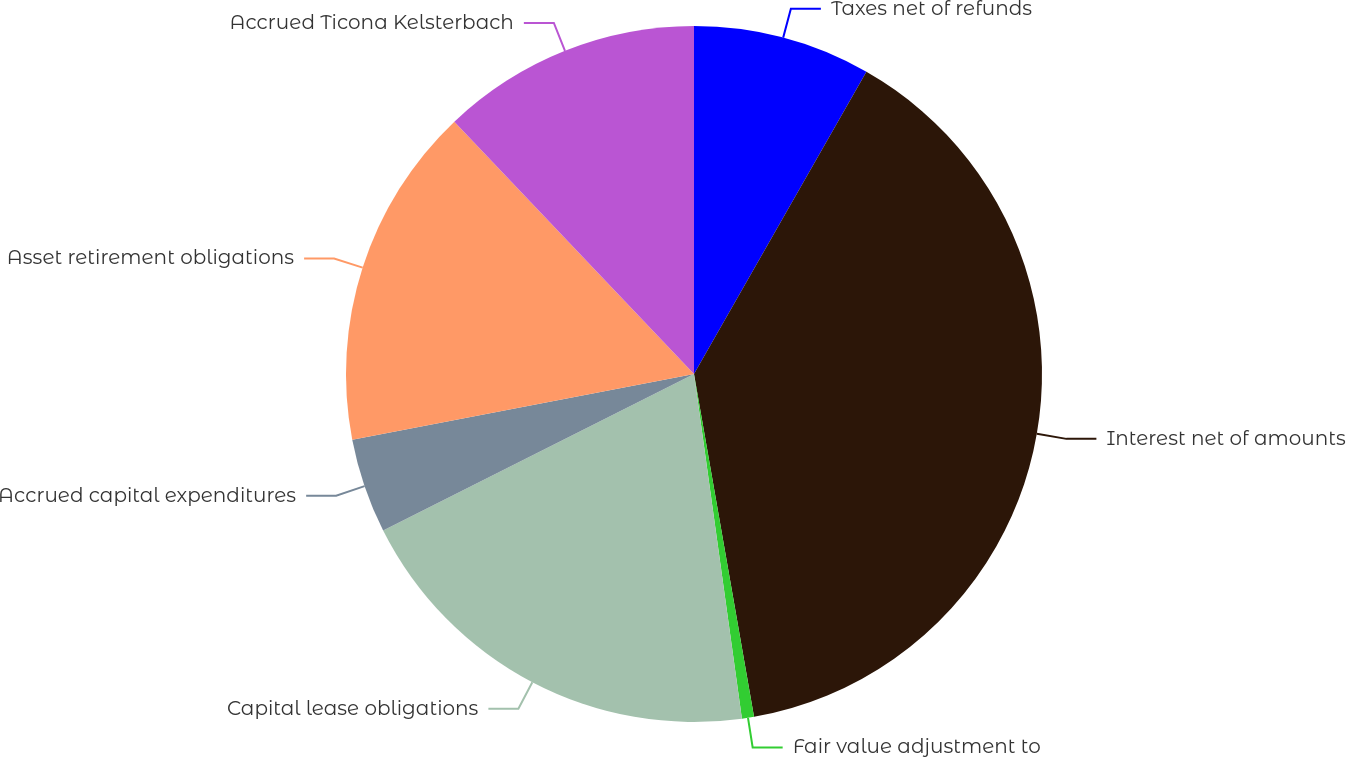<chart> <loc_0><loc_0><loc_500><loc_500><pie_chart><fcel>Taxes net of refunds<fcel>Interest net of amounts<fcel>Fair value adjustment to<fcel>Capital lease obligations<fcel>Accrued capital expenditures<fcel>Asset retirement obligations<fcel>Accrued Ticona Kelsterbach<nl><fcel>8.25%<fcel>38.99%<fcel>0.56%<fcel>19.78%<fcel>4.4%<fcel>15.93%<fcel>12.09%<nl></chart> 